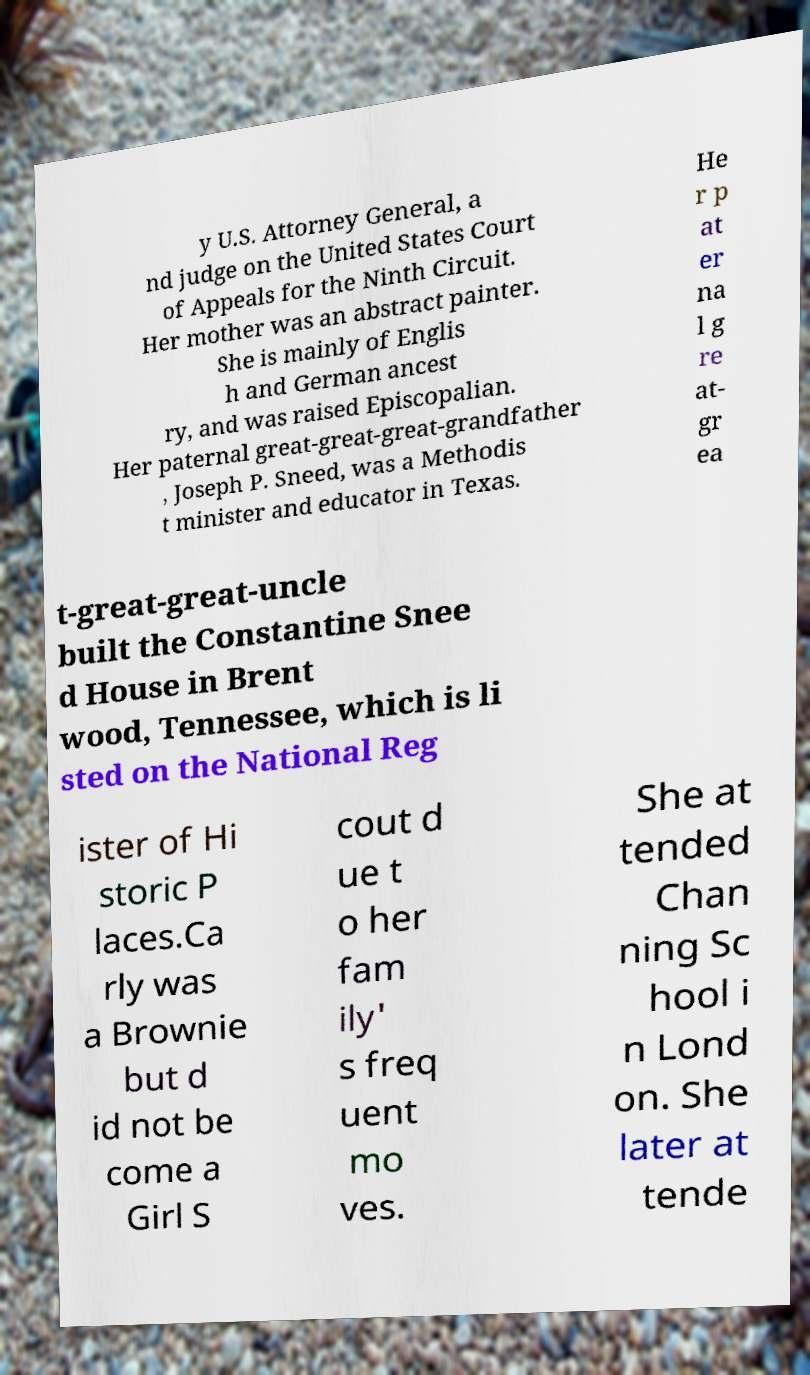Could you extract and type out the text from this image? y U.S. Attorney General, a nd judge on the United States Court of Appeals for the Ninth Circuit. Her mother was an abstract painter. She is mainly of Englis h and German ancest ry, and was raised Episcopalian. Her paternal great-great-great-grandfather , Joseph P. Sneed, was a Methodis t minister and educator in Texas. He r p at er na l g re at- gr ea t-great-great-uncle built the Constantine Snee d House in Brent wood, Tennessee, which is li sted on the National Reg ister of Hi storic P laces.Ca rly was a Brownie but d id not be come a Girl S cout d ue t o her fam ily' s freq uent mo ves. She at tended Chan ning Sc hool i n Lond on. She later at tende 